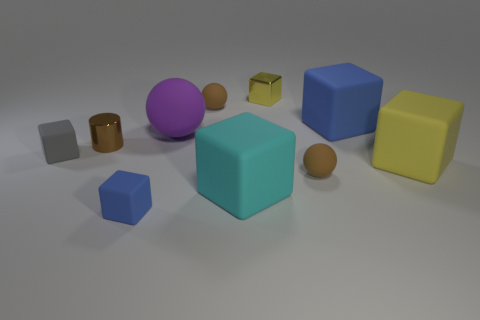Are there any blue things in front of the big blue object?
Ensure brevity in your answer.  Yes. What is the large purple sphere made of?
Your answer should be very brief. Rubber. What is the shape of the small metallic thing that is to the left of the cyan matte object?
Make the answer very short. Cylinder. Are there any brown cylinders of the same size as the shiny cube?
Give a very brief answer. Yes. Is the block that is behind the large blue thing made of the same material as the tiny brown cylinder?
Your answer should be compact. Yes. Are there the same number of tiny yellow things in front of the big cyan rubber cube and gray rubber things right of the big purple sphere?
Your answer should be very brief. Yes. What is the shape of the large matte thing that is both on the left side of the small yellow shiny thing and behind the cyan object?
Your response must be concise. Sphere. There is a tiny yellow block; how many brown spheres are on the left side of it?
Your response must be concise. 1. How many other objects are there of the same shape as the gray thing?
Your answer should be compact. 5. Are there fewer gray rubber objects than tiny shiny things?
Ensure brevity in your answer.  Yes. 